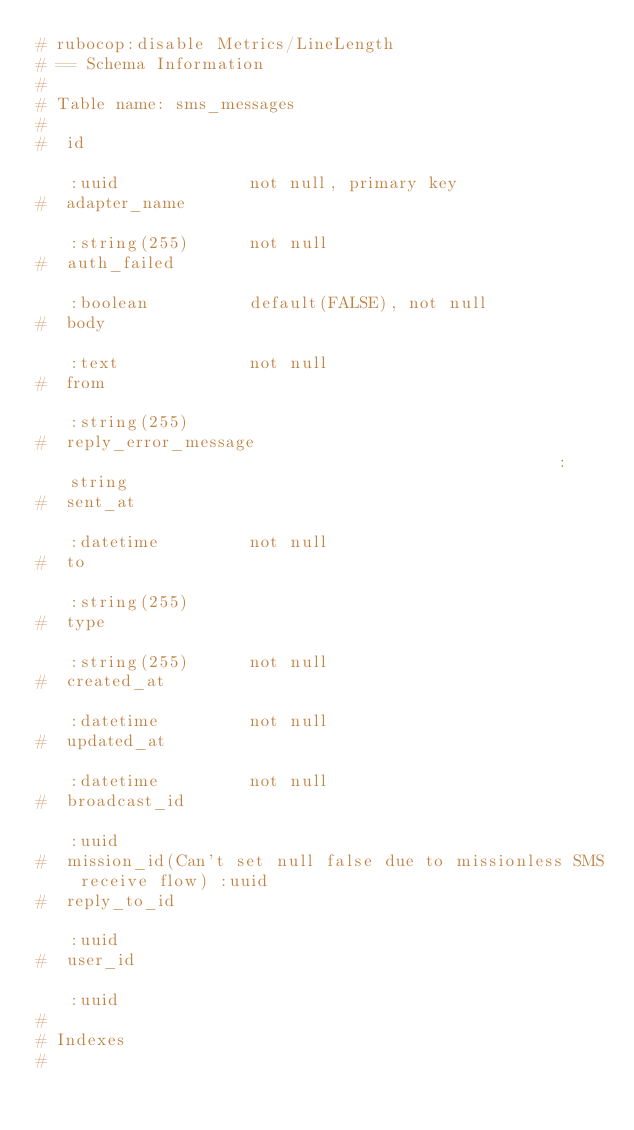<code> <loc_0><loc_0><loc_500><loc_500><_Ruby_># rubocop:disable Metrics/LineLength
# == Schema Information
#
# Table name: sms_messages
#
#  id                                                                   :uuid             not null, primary key
#  adapter_name                                                         :string(255)      not null
#  auth_failed                                                          :boolean          default(FALSE), not null
#  body                                                                 :text             not null
#  from                                                                 :string(255)
#  reply_error_message                                                  :string
#  sent_at                                                              :datetime         not null
#  to                                                                   :string(255)
#  type                                                                 :string(255)      not null
#  created_at                                                           :datetime         not null
#  updated_at                                                           :datetime         not null
#  broadcast_id                                                         :uuid
#  mission_id(Can't set null false due to missionless SMS receive flow) :uuid
#  reply_to_id                                                          :uuid
#  user_id                                                              :uuid
#
# Indexes
#</code> 